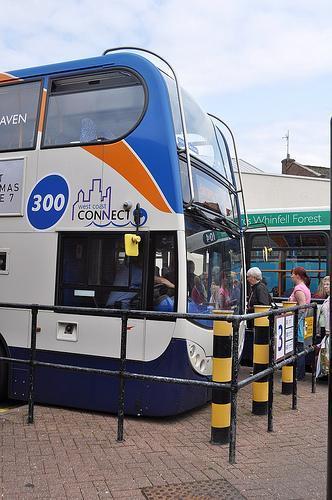How many buses are there?
Give a very brief answer. 1. 